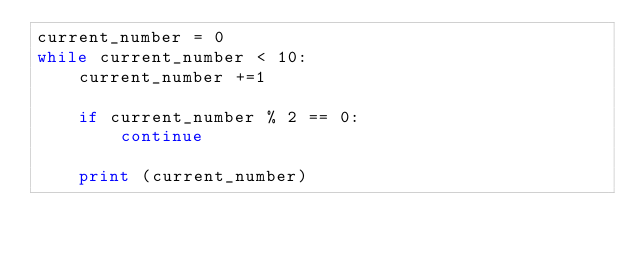Convert code to text. <code><loc_0><loc_0><loc_500><loc_500><_Python_>current_number = 0
while current_number < 10:
    current_number +=1

    if current_number % 2 == 0:
        continue

    print (current_number)
</code> 